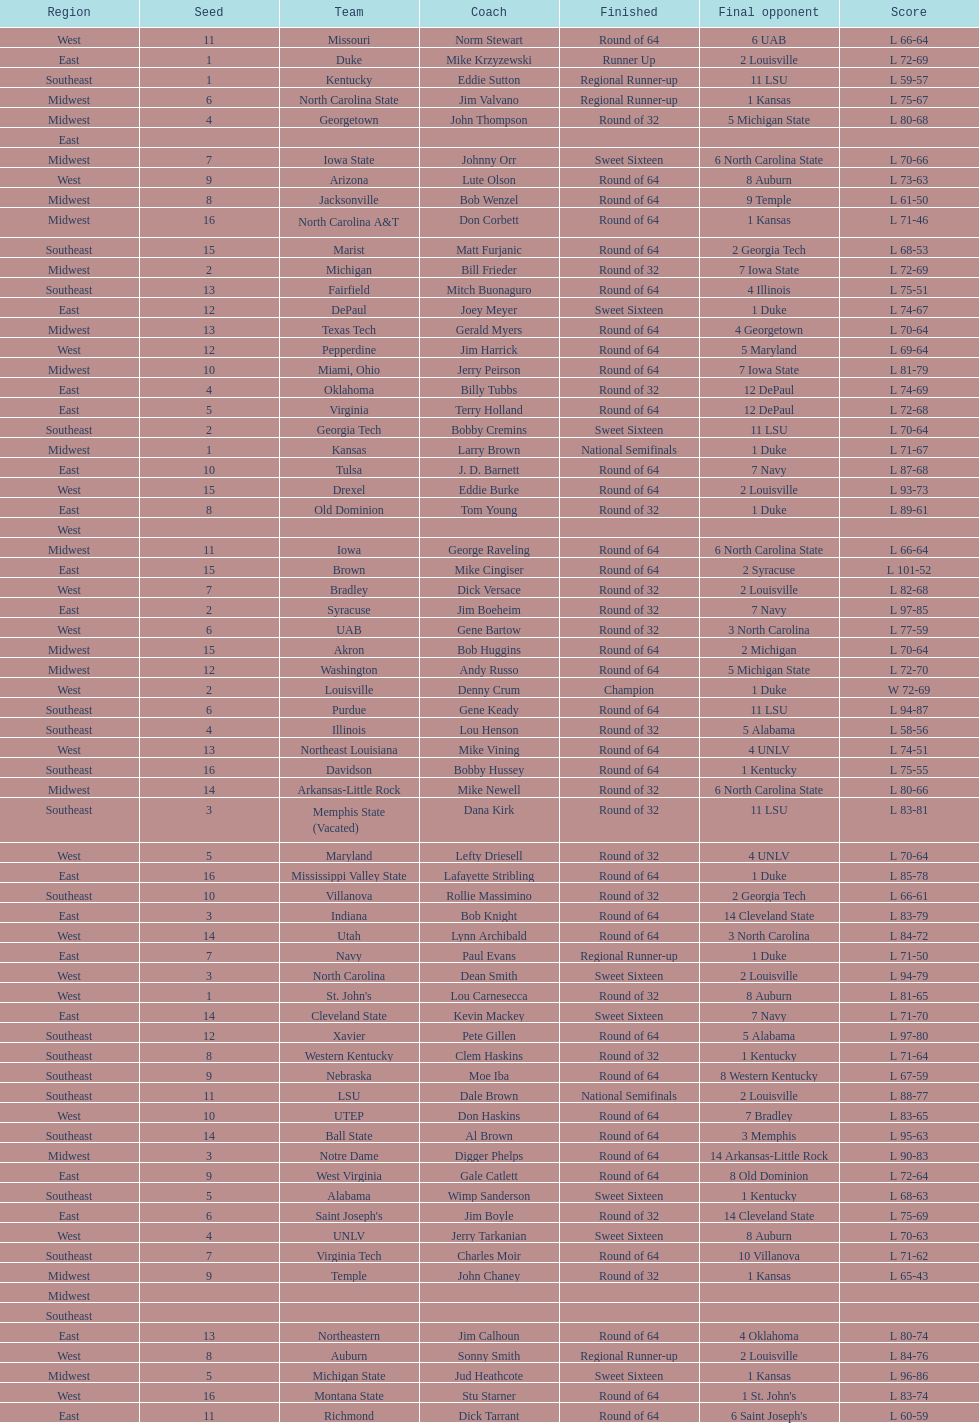North carolina and unlv each made it to which round? Sweet Sixteen. 